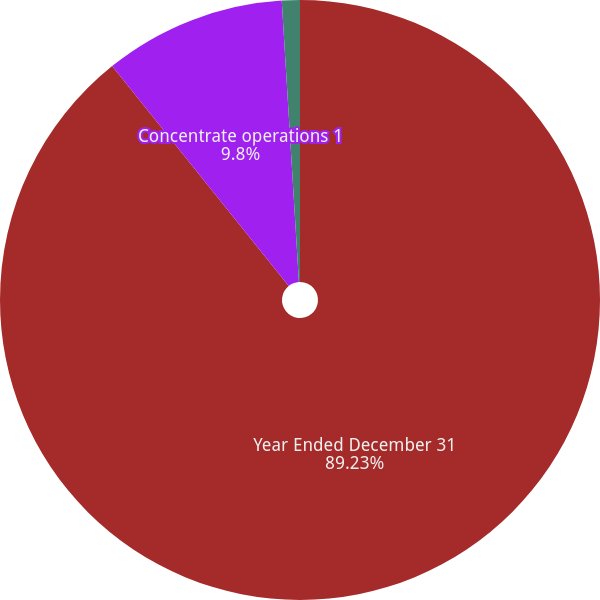<chart> <loc_0><loc_0><loc_500><loc_500><pie_chart><fcel>Year Ended December 31<fcel>Concentrate operations 1<fcel>Finished product operations 2<nl><fcel>89.23%<fcel>9.8%<fcel>0.97%<nl></chart> 